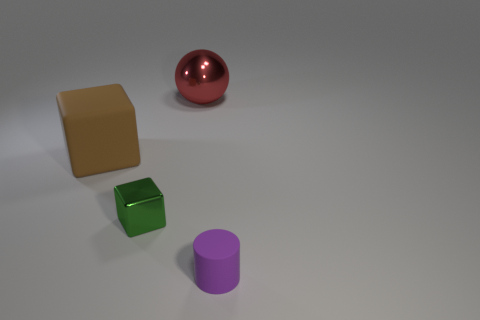What is the material of the other big thing that is the same shape as the green object?
Provide a short and direct response. Rubber. What material is the object that is both left of the red ball and behind the small green thing?
Offer a very short reply. Rubber. How big is the brown rubber block that is left of the shiny object that is behind the tiny green metal cube?
Make the answer very short. Large. What material is the big red object?
Your response must be concise. Metal. Are there any big cyan metal balls?
Your response must be concise. No. Are there the same number of small cylinders that are on the left side of the green thing and small brown things?
Your response must be concise. Yes. How many large objects are either blue cylinders or green shiny objects?
Offer a very short reply. 0. Is the cube that is left of the tiny metallic object made of the same material as the small green thing?
Ensure brevity in your answer.  No. The big thing on the right side of the metallic thing that is in front of the brown thing is made of what material?
Offer a terse response. Metal. What number of tiny green shiny objects are the same shape as the big rubber object?
Offer a very short reply. 1. 